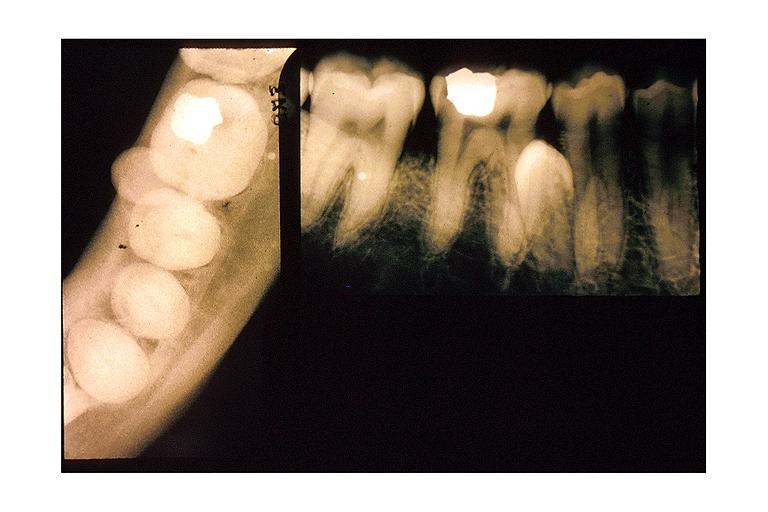what does this image show?
Answer the question using a single word or phrase. Impacted supernumerary tooth 